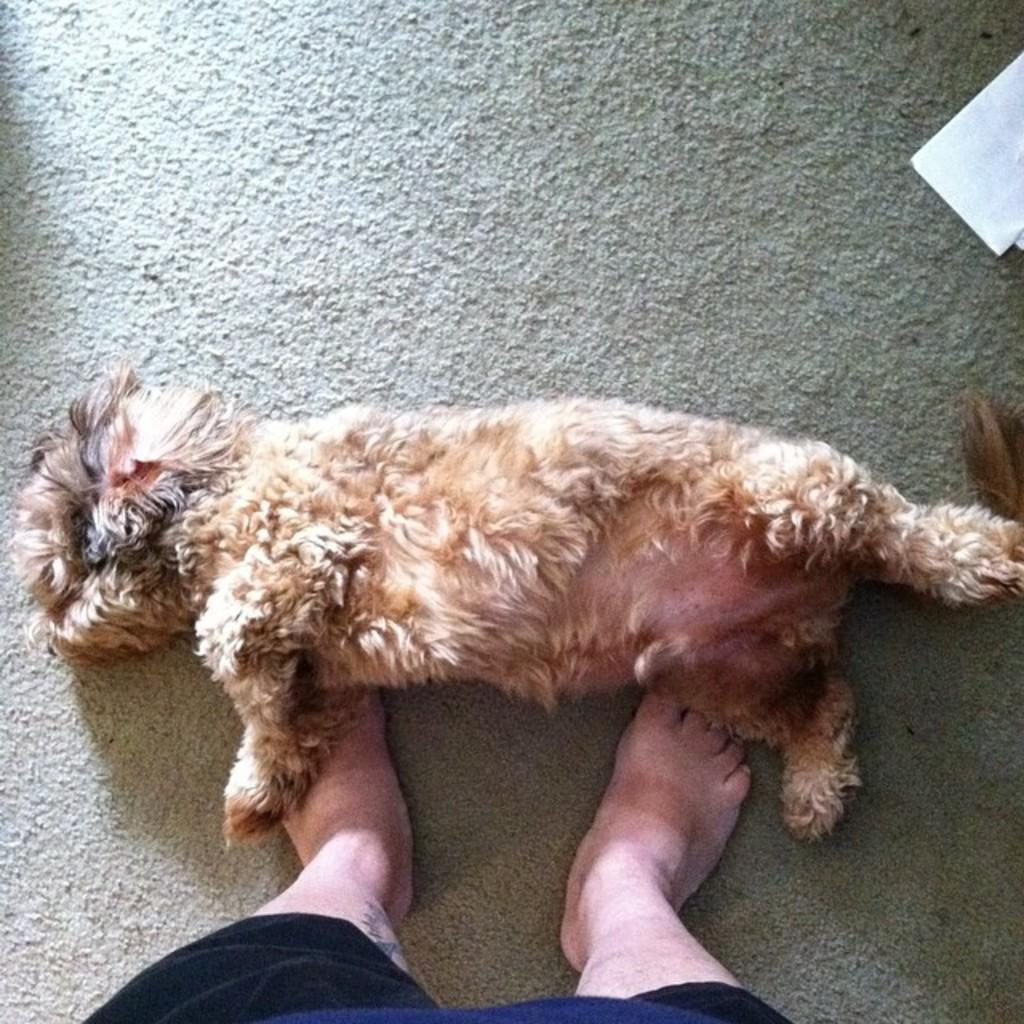Who or what is at the bottom of the image? There is a person at the bottom of the image. What is the person doing or interacting with in the image? The person is at the bottom of the image, but the specific activity or interaction is not mentioned in the facts. What type of animal is laying in the image? The facts do not specify the type of animal, only that there is an animal laying in the image. What is the person standing or sitting on in the image? There is a mat at the bottom of the image. What organization is responsible for the stocking of the drop in the image? There is no mention of a drop, stocking, or organization in the image or the provided facts. 